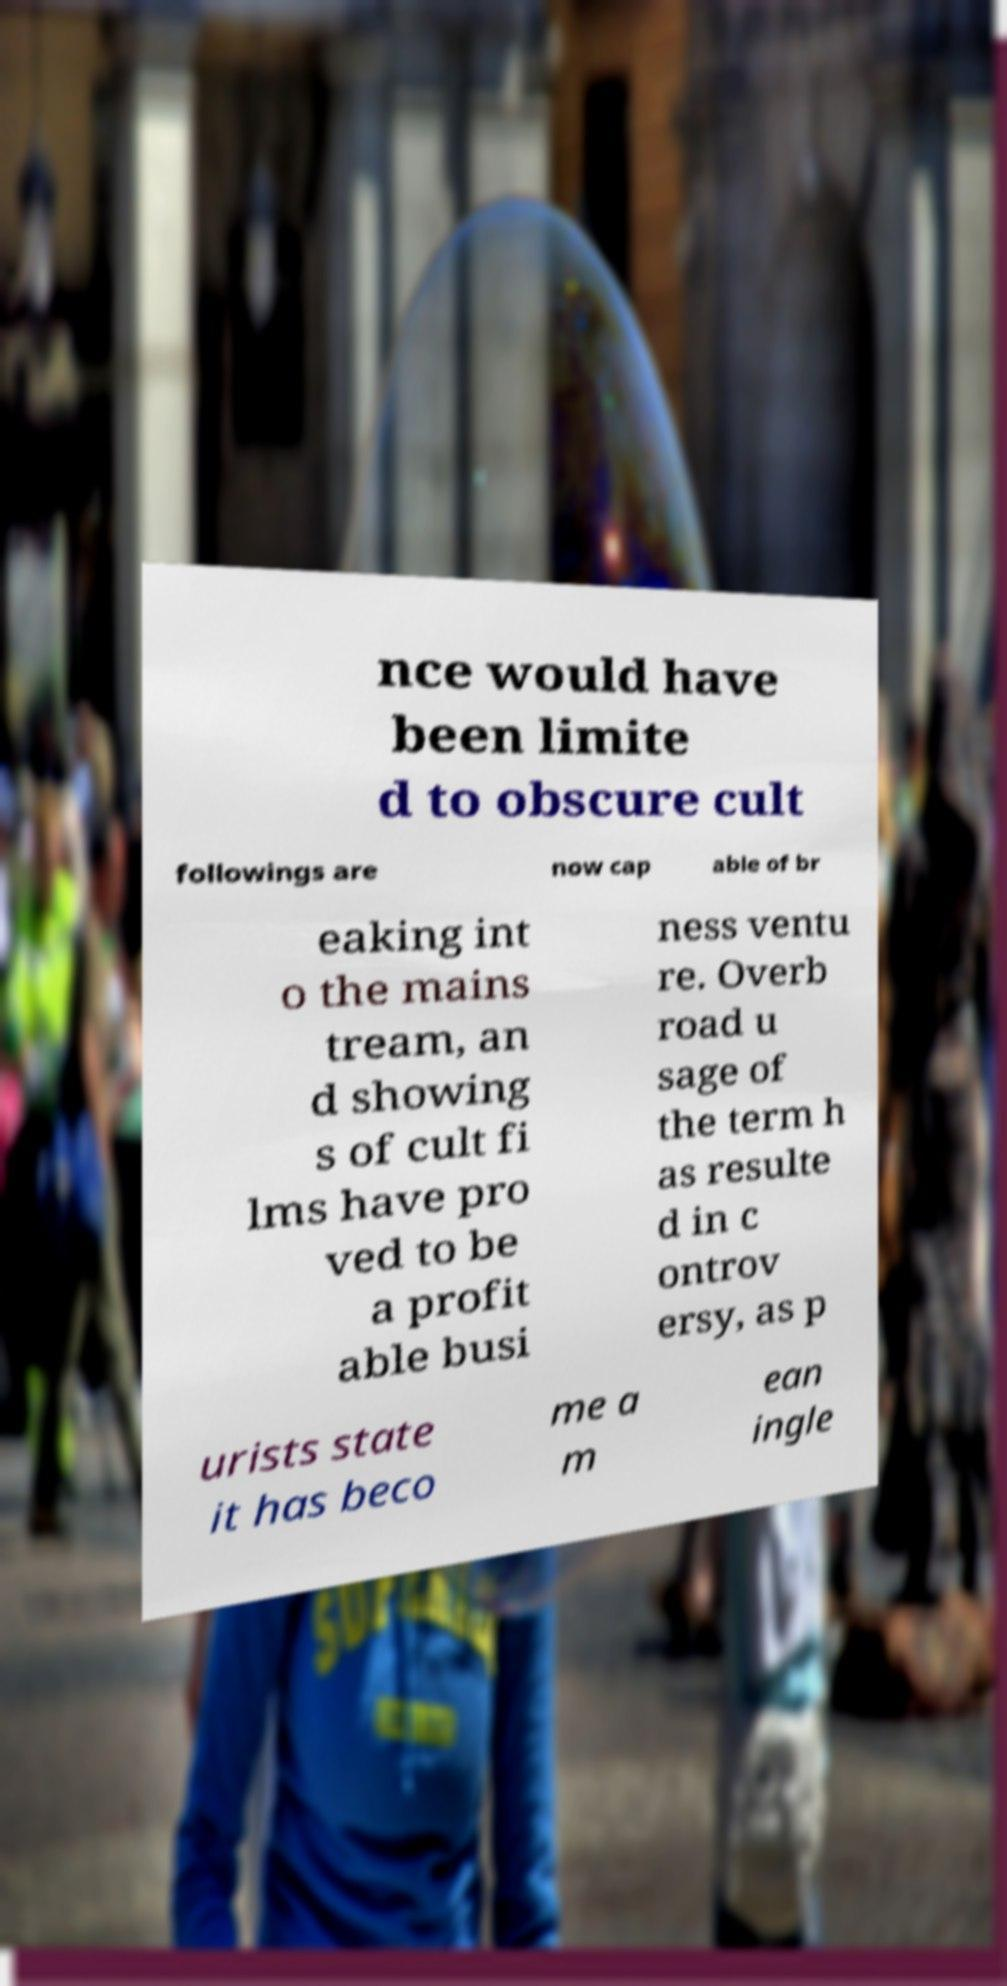Could you extract and type out the text from this image? nce would have been limite d to obscure cult followings are now cap able of br eaking int o the mains tream, an d showing s of cult fi lms have pro ved to be a profit able busi ness ventu re. Overb road u sage of the term h as resulte d in c ontrov ersy, as p urists state it has beco me a m ean ingle 